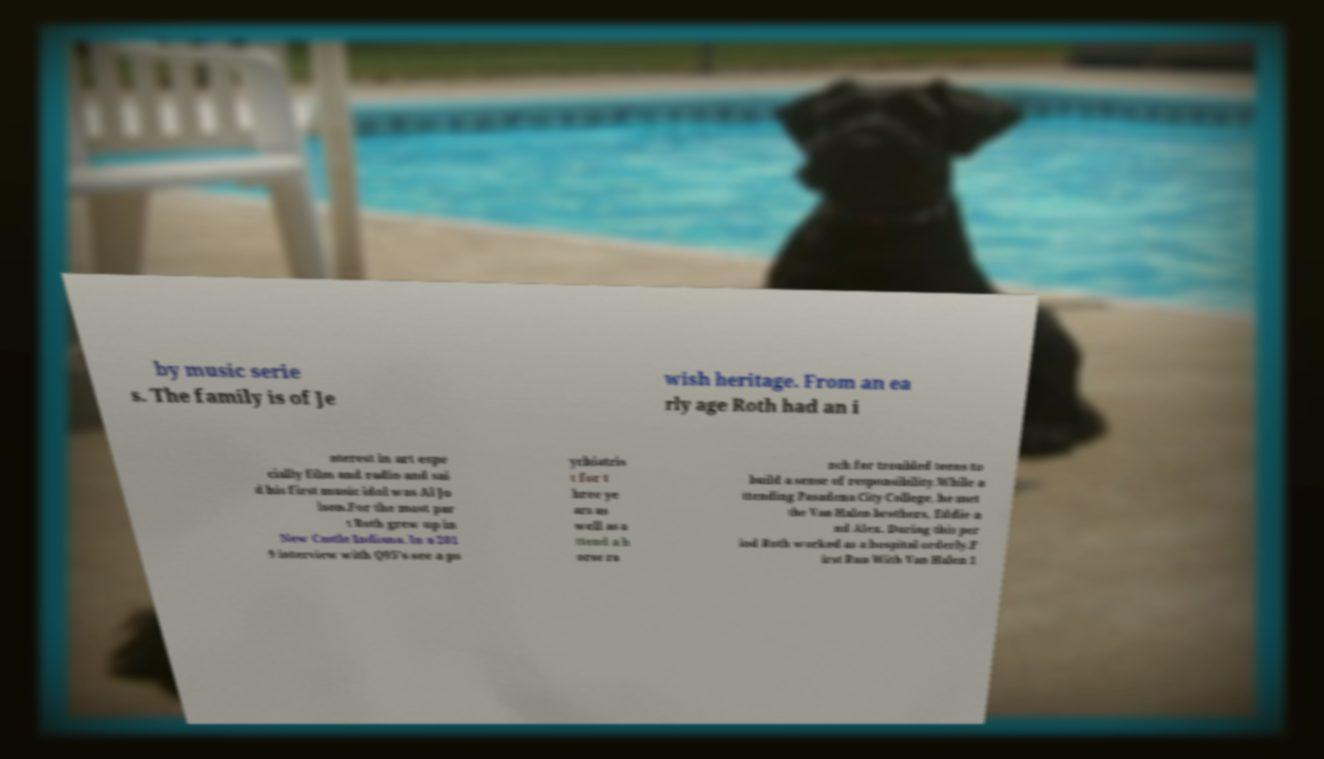Can you read and provide the text displayed in the image?This photo seems to have some interesting text. Can you extract and type it out for me? by music serie s. The family is of Je wish heritage. From an ea rly age Roth had an i nterest in art espe cially film and radio and sai d his first music idol was Al Jo lson.For the most par t Roth grew up in New Castle Indiana. In a 201 9 interview with Q95's see a ps ychiatris t for t hree ye ars as well as a ttend a h orse ra nch for troubled teens to build a sense of responsibility.While a ttending Pasadena City College, he met the Van Halen brothers, Eddie a nd Alex. During this per iod Roth worked as a hospital orderly.F irst Run With Van Halen 1 